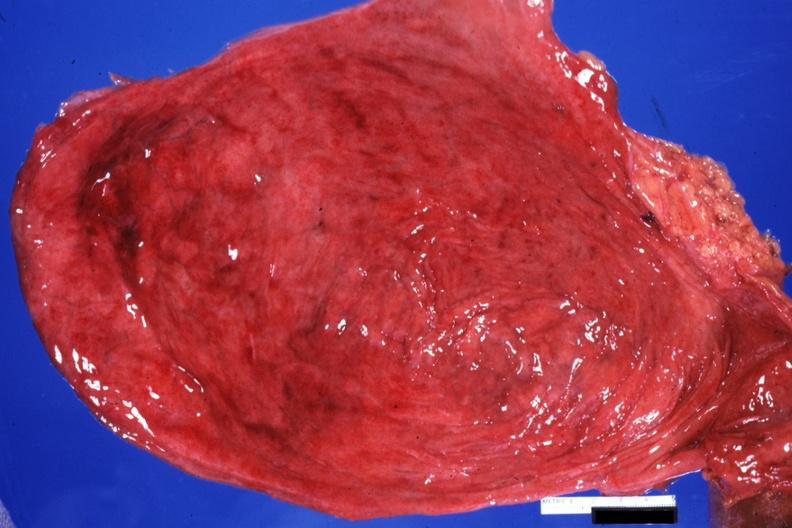what is present?
Answer the question using a single word or phrase. Hypertrophy and hemorrhagic cystitis 